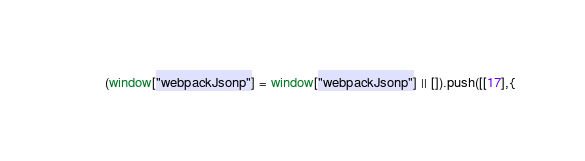Convert code to text. <code><loc_0><loc_0><loc_500><loc_500><_JavaScript_>(window["webpackJsonp"] = window["webpackJsonp"] || []).push([[17],{
</code> 